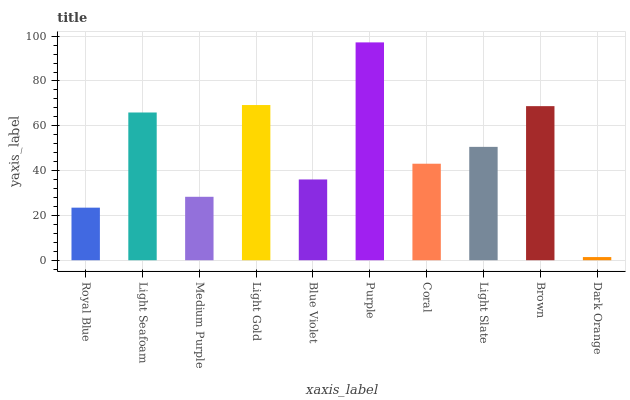Is Dark Orange the minimum?
Answer yes or no. Yes. Is Purple the maximum?
Answer yes or no. Yes. Is Light Seafoam the minimum?
Answer yes or no. No. Is Light Seafoam the maximum?
Answer yes or no. No. Is Light Seafoam greater than Royal Blue?
Answer yes or no. Yes. Is Royal Blue less than Light Seafoam?
Answer yes or no. Yes. Is Royal Blue greater than Light Seafoam?
Answer yes or no. No. Is Light Seafoam less than Royal Blue?
Answer yes or no. No. Is Light Slate the high median?
Answer yes or no. Yes. Is Coral the low median?
Answer yes or no. Yes. Is Medium Purple the high median?
Answer yes or no. No. Is Light Seafoam the low median?
Answer yes or no. No. 